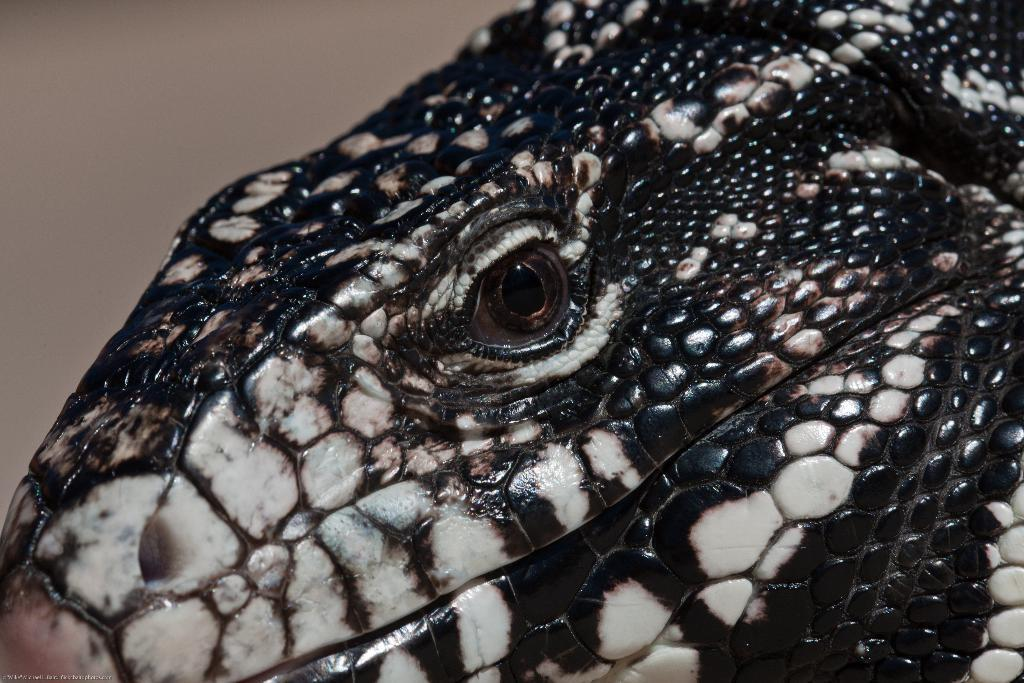What type of animal can be seen in the image? There is a black color animal in the image. What is visible in the background of the image? There is a wall in the background of the image. Is the animal blowing on the wall in the image? There is no indication in the image that the animal is blowing on the wall. 